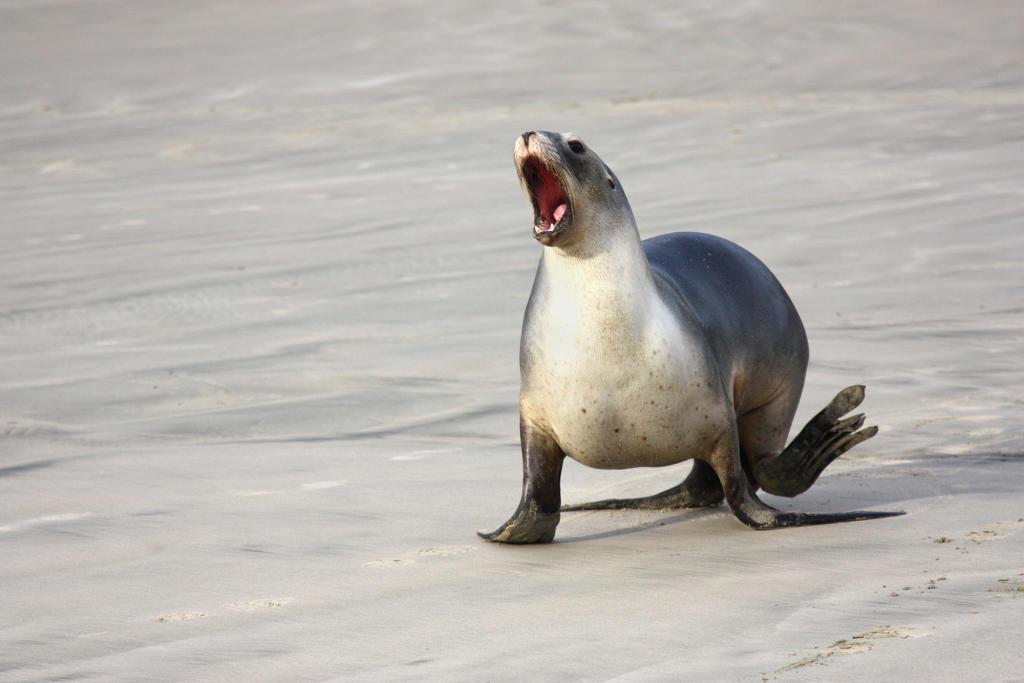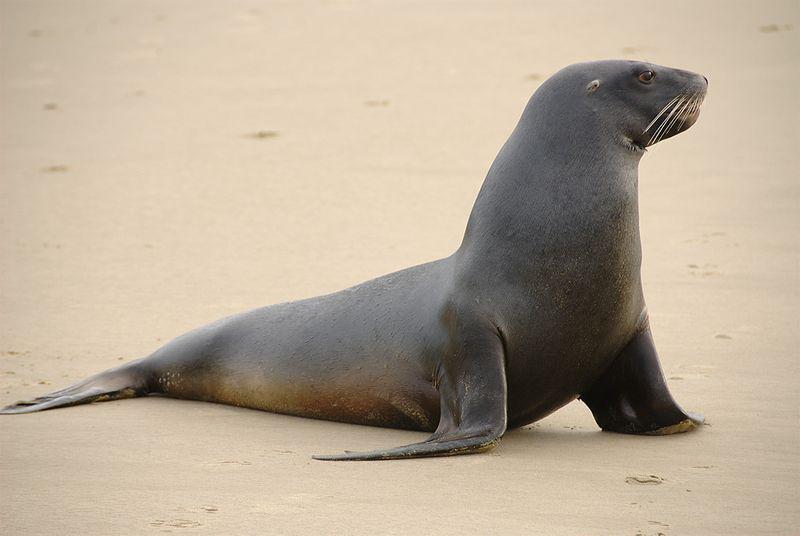The first image is the image on the left, the second image is the image on the right. Considering the images on both sides, is "Three toes can be counted in the image on the left." valid? Answer yes or no. Yes. 